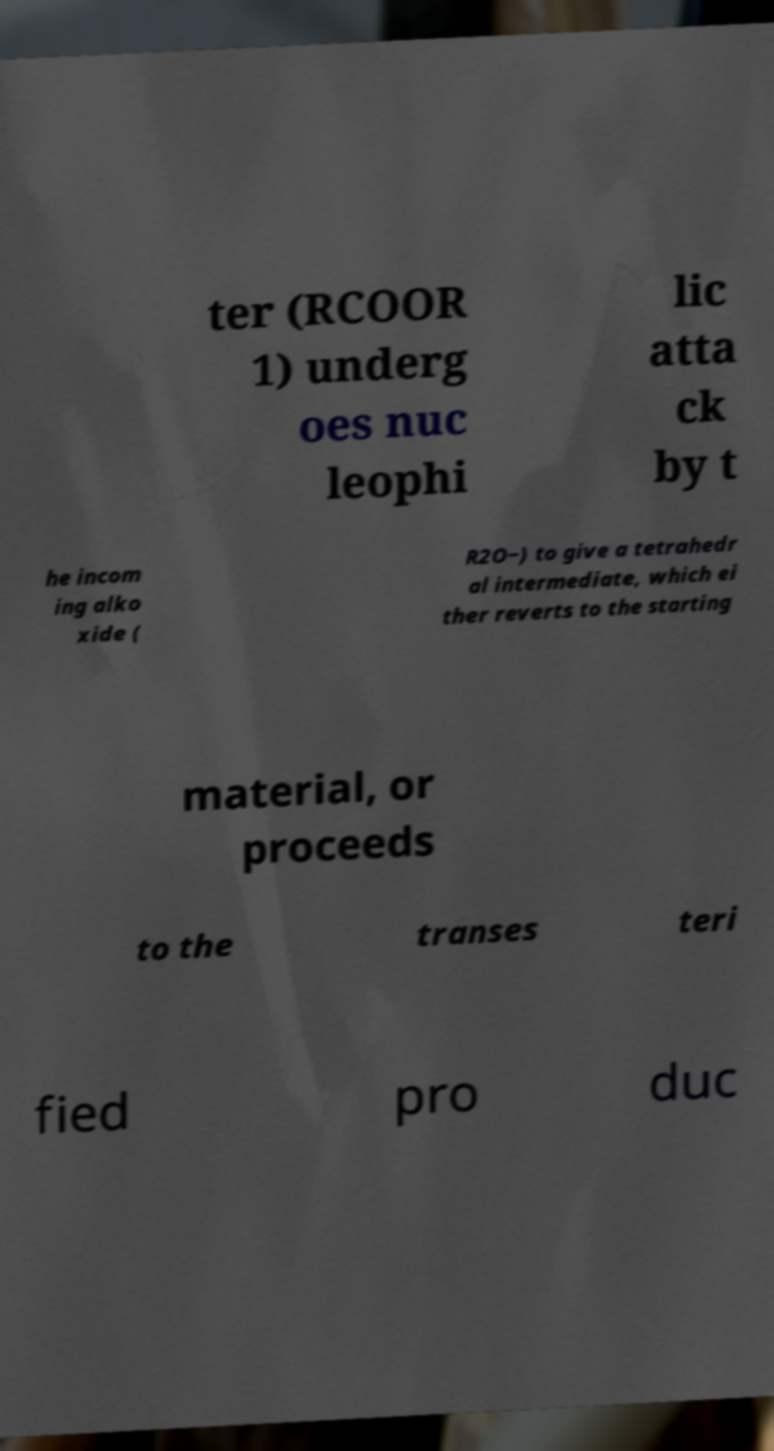Could you assist in decoding the text presented in this image and type it out clearly? ter (RCOOR 1) underg oes nuc leophi lic atta ck by t he incom ing alko xide ( R2O−) to give a tetrahedr al intermediate, which ei ther reverts to the starting material, or proceeds to the transes teri fied pro duc 